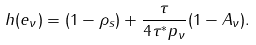Convert formula to latex. <formula><loc_0><loc_0><loc_500><loc_500>h ( { e } _ { \nu } ) = ( 1 - \rho _ { s } ) + \frac { \tau } { 4 \tau ^ { * } p _ { \nu } } ( 1 - A _ { \nu } ) .</formula> 